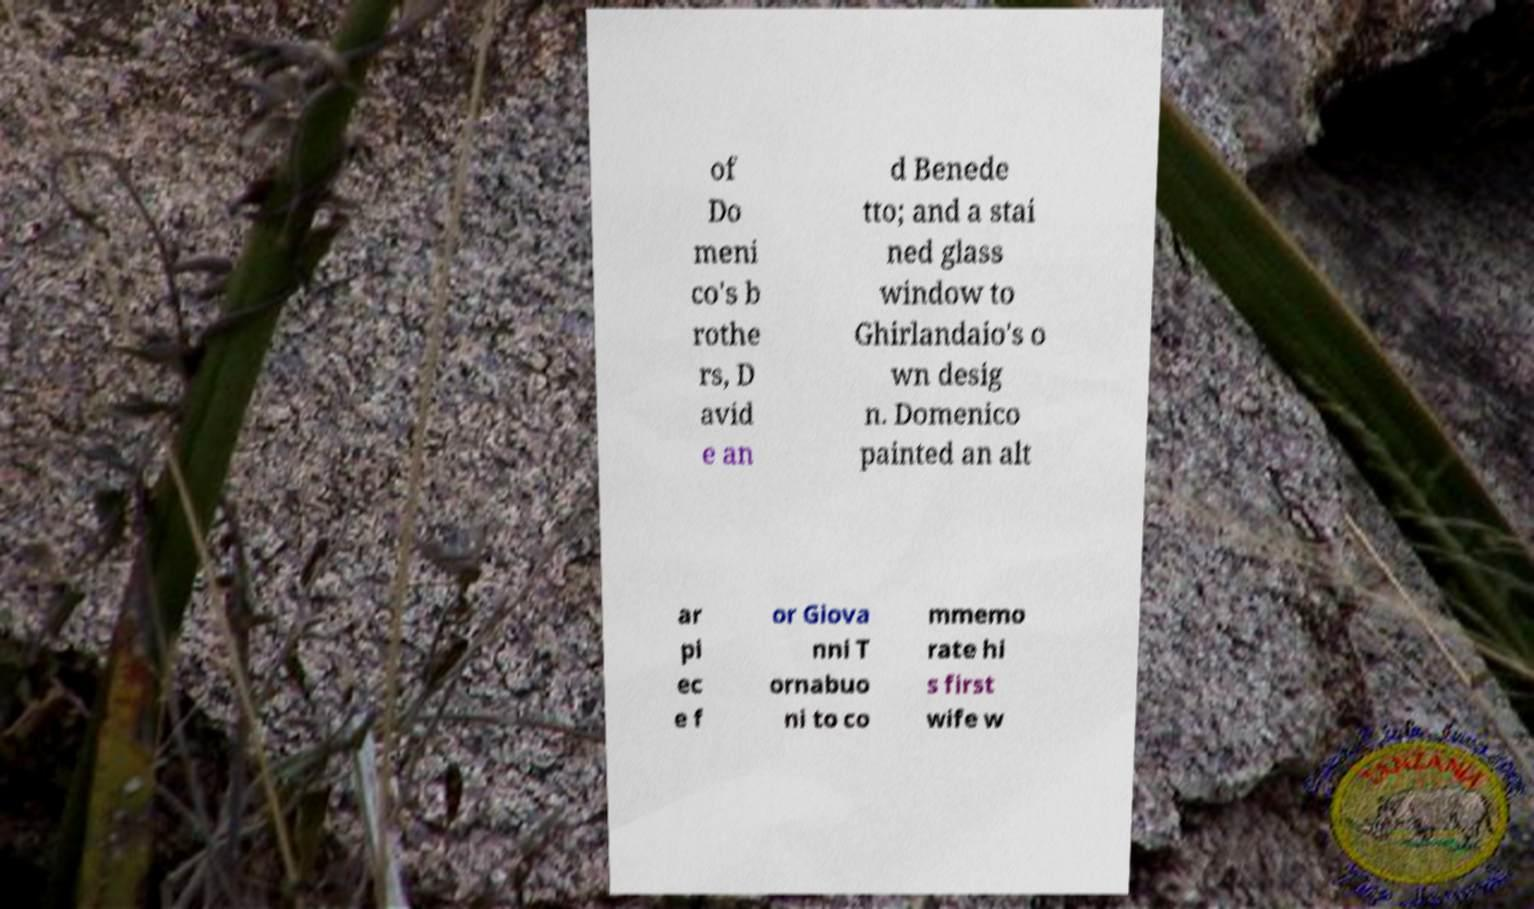Could you extract and type out the text from this image? of Do meni co's b rothe rs, D avid e an d Benede tto; and a stai ned glass window to Ghirlandaio's o wn desig n. Domenico painted an alt ar pi ec e f or Giova nni T ornabuo ni to co mmemo rate hi s first wife w 